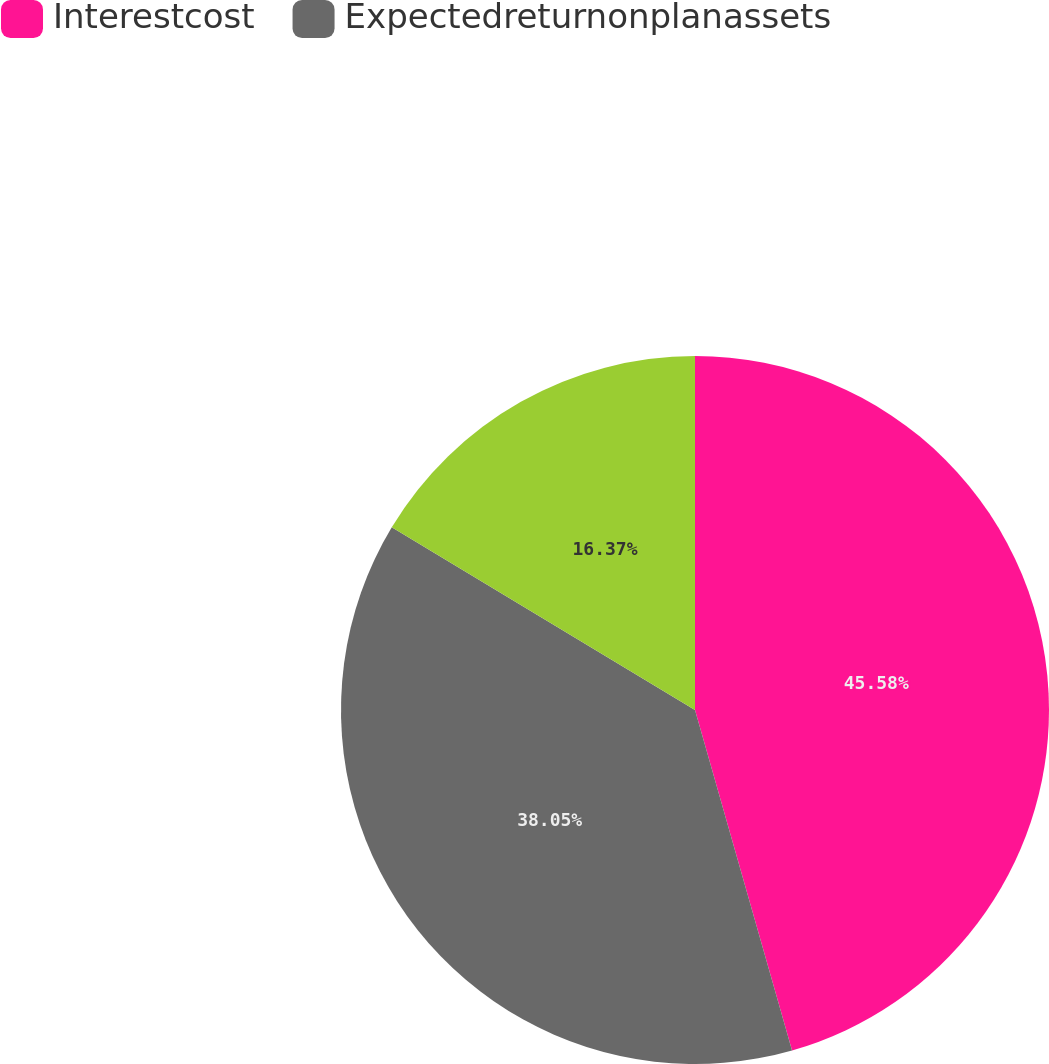Convert chart. <chart><loc_0><loc_0><loc_500><loc_500><pie_chart><fcel>Interestcost<fcel>Expectedreturnonplanassets<fcel>Unnamed: 2<nl><fcel>45.58%<fcel>38.05%<fcel>16.37%<nl></chart> 